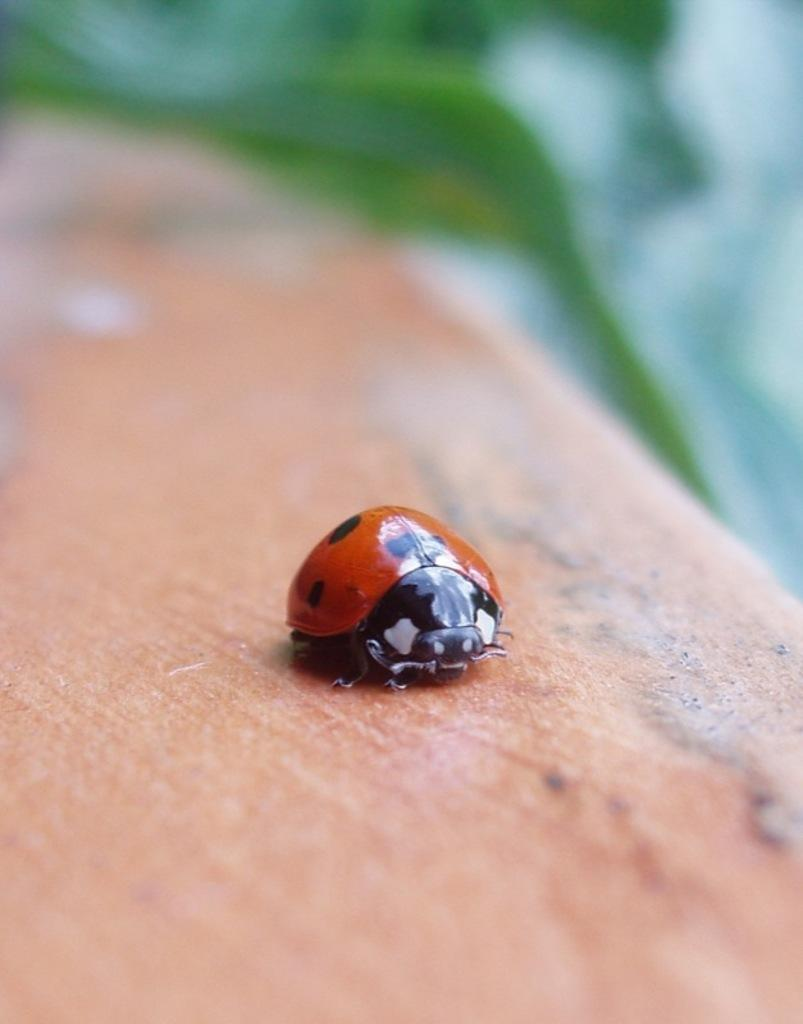What type of creature can be seen on the surface in the image? There is an insect on the surface in the image. What type of plant material is visible towards the top of the image? There is a leaf towards the top of the image. Can you describe the quality of the image at the top? The top of the image is blurred. What type of development is the snake undergoing in the image? There is no snake present in the image, so there is no development to discuss. 